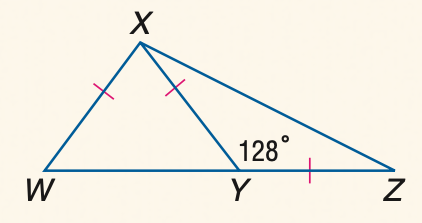Question: \triangle W X Y and \triangle X Y Z are isosceles and m \angle X Y Z = 128. Find the measure of \angle W X Y.
Choices:
A. 72
B. 74
C. 76
D. 78
Answer with the letter. Answer: C 